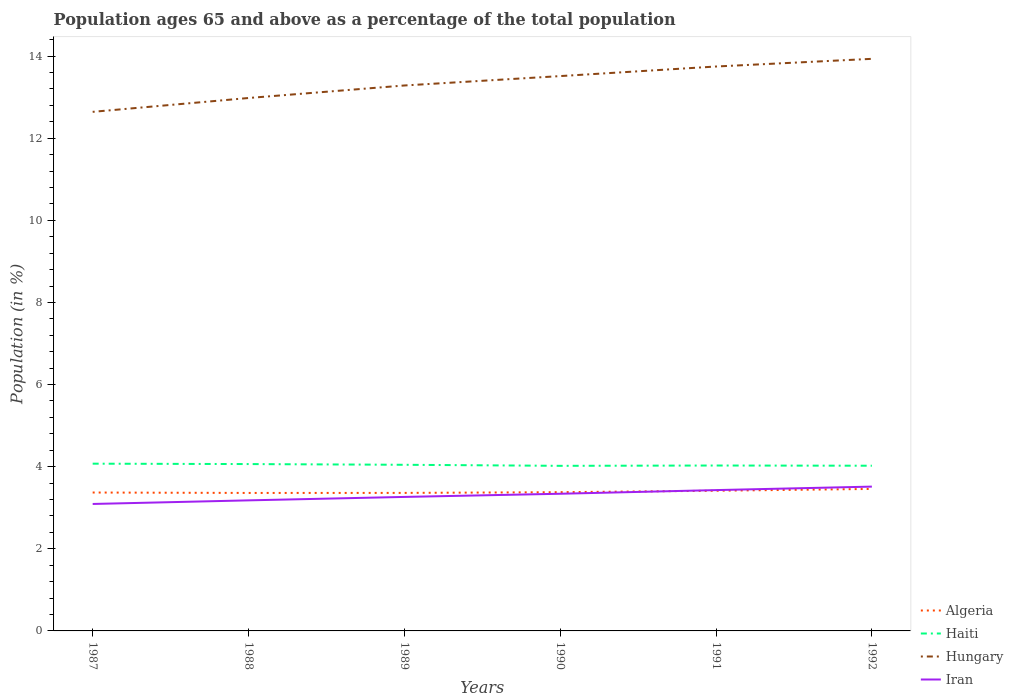How many different coloured lines are there?
Offer a terse response. 4. Across all years, what is the maximum percentage of the population ages 65 and above in Iran?
Offer a terse response. 3.09. What is the total percentage of the population ages 65 and above in Haiti in the graph?
Your response must be concise. 0. What is the difference between the highest and the second highest percentage of the population ages 65 and above in Hungary?
Ensure brevity in your answer.  1.29. What is the difference between the highest and the lowest percentage of the population ages 65 and above in Iran?
Offer a very short reply. 3. Is the percentage of the population ages 65 and above in Algeria strictly greater than the percentage of the population ages 65 and above in Hungary over the years?
Provide a succinct answer. Yes. How many lines are there?
Offer a terse response. 4. How many years are there in the graph?
Your response must be concise. 6. Are the values on the major ticks of Y-axis written in scientific E-notation?
Your response must be concise. No. Where does the legend appear in the graph?
Ensure brevity in your answer.  Bottom right. How are the legend labels stacked?
Your answer should be compact. Vertical. What is the title of the graph?
Keep it short and to the point. Population ages 65 and above as a percentage of the total population. Does "Least developed countries" appear as one of the legend labels in the graph?
Provide a short and direct response. No. What is the label or title of the X-axis?
Ensure brevity in your answer.  Years. What is the label or title of the Y-axis?
Provide a short and direct response. Population (in %). What is the Population (in %) of Algeria in 1987?
Keep it short and to the point. 3.37. What is the Population (in %) of Haiti in 1987?
Give a very brief answer. 4.07. What is the Population (in %) of Hungary in 1987?
Keep it short and to the point. 12.64. What is the Population (in %) of Iran in 1987?
Keep it short and to the point. 3.09. What is the Population (in %) in Algeria in 1988?
Offer a very short reply. 3.36. What is the Population (in %) in Haiti in 1988?
Offer a very short reply. 4.06. What is the Population (in %) of Hungary in 1988?
Keep it short and to the point. 12.98. What is the Population (in %) in Iran in 1988?
Your answer should be compact. 3.18. What is the Population (in %) in Algeria in 1989?
Provide a short and direct response. 3.36. What is the Population (in %) of Haiti in 1989?
Offer a terse response. 4.05. What is the Population (in %) of Hungary in 1989?
Offer a very short reply. 13.28. What is the Population (in %) in Iran in 1989?
Ensure brevity in your answer.  3.26. What is the Population (in %) of Algeria in 1990?
Keep it short and to the point. 3.38. What is the Population (in %) in Haiti in 1990?
Give a very brief answer. 4.02. What is the Population (in %) of Hungary in 1990?
Offer a very short reply. 13.51. What is the Population (in %) of Iran in 1990?
Your response must be concise. 3.34. What is the Population (in %) in Algeria in 1991?
Make the answer very short. 3.41. What is the Population (in %) of Haiti in 1991?
Keep it short and to the point. 4.03. What is the Population (in %) in Hungary in 1991?
Provide a short and direct response. 13.75. What is the Population (in %) in Iran in 1991?
Keep it short and to the point. 3.43. What is the Population (in %) in Algeria in 1992?
Provide a succinct answer. 3.46. What is the Population (in %) of Haiti in 1992?
Your response must be concise. 4.02. What is the Population (in %) of Hungary in 1992?
Provide a succinct answer. 13.93. What is the Population (in %) of Iran in 1992?
Your response must be concise. 3.51. Across all years, what is the maximum Population (in %) in Algeria?
Your response must be concise. 3.46. Across all years, what is the maximum Population (in %) of Haiti?
Give a very brief answer. 4.07. Across all years, what is the maximum Population (in %) in Hungary?
Keep it short and to the point. 13.93. Across all years, what is the maximum Population (in %) of Iran?
Ensure brevity in your answer.  3.51. Across all years, what is the minimum Population (in %) in Algeria?
Keep it short and to the point. 3.36. Across all years, what is the minimum Population (in %) in Haiti?
Ensure brevity in your answer.  4.02. Across all years, what is the minimum Population (in %) of Hungary?
Make the answer very short. 12.64. Across all years, what is the minimum Population (in %) in Iran?
Ensure brevity in your answer.  3.09. What is the total Population (in %) of Algeria in the graph?
Your answer should be compact. 20.34. What is the total Population (in %) in Haiti in the graph?
Offer a terse response. 24.25. What is the total Population (in %) in Hungary in the graph?
Offer a very short reply. 80.09. What is the total Population (in %) in Iran in the graph?
Ensure brevity in your answer.  19.82. What is the difference between the Population (in %) of Algeria in 1987 and that in 1988?
Keep it short and to the point. 0.01. What is the difference between the Population (in %) in Haiti in 1987 and that in 1988?
Your response must be concise. 0.01. What is the difference between the Population (in %) in Hungary in 1987 and that in 1988?
Your answer should be very brief. -0.34. What is the difference between the Population (in %) in Iran in 1987 and that in 1988?
Provide a short and direct response. -0.09. What is the difference between the Population (in %) of Algeria in 1987 and that in 1989?
Offer a very short reply. 0.01. What is the difference between the Population (in %) of Haiti in 1987 and that in 1989?
Ensure brevity in your answer.  0.03. What is the difference between the Population (in %) of Hungary in 1987 and that in 1989?
Keep it short and to the point. -0.64. What is the difference between the Population (in %) in Iran in 1987 and that in 1989?
Keep it short and to the point. -0.17. What is the difference between the Population (in %) in Algeria in 1987 and that in 1990?
Keep it short and to the point. -0.01. What is the difference between the Population (in %) in Haiti in 1987 and that in 1990?
Provide a short and direct response. 0.05. What is the difference between the Population (in %) of Hungary in 1987 and that in 1990?
Your response must be concise. -0.87. What is the difference between the Population (in %) in Iran in 1987 and that in 1990?
Give a very brief answer. -0.25. What is the difference between the Population (in %) in Algeria in 1987 and that in 1991?
Offer a very short reply. -0.04. What is the difference between the Population (in %) in Haiti in 1987 and that in 1991?
Give a very brief answer. 0.04. What is the difference between the Population (in %) of Hungary in 1987 and that in 1991?
Your answer should be very brief. -1.1. What is the difference between the Population (in %) in Iran in 1987 and that in 1991?
Your answer should be compact. -0.34. What is the difference between the Population (in %) in Algeria in 1987 and that in 1992?
Provide a short and direct response. -0.09. What is the difference between the Population (in %) of Haiti in 1987 and that in 1992?
Your answer should be compact. 0.05. What is the difference between the Population (in %) of Hungary in 1987 and that in 1992?
Keep it short and to the point. -1.29. What is the difference between the Population (in %) in Iran in 1987 and that in 1992?
Provide a short and direct response. -0.42. What is the difference between the Population (in %) of Algeria in 1988 and that in 1989?
Give a very brief answer. -0. What is the difference between the Population (in %) in Haiti in 1988 and that in 1989?
Offer a very short reply. 0.02. What is the difference between the Population (in %) in Hungary in 1988 and that in 1989?
Give a very brief answer. -0.3. What is the difference between the Population (in %) of Iran in 1988 and that in 1989?
Give a very brief answer. -0.08. What is the difference between the Population (in %) in Algeria in 1988 and that in 1990?
Give a very brief answer. -0.02. What is the difference between the Population (in %) in Haiti in 1988 and that in 1990?
Offer a terse response. 0.04. What is the difference between the Population (in %) in Hungary in 1988 and that in 1990?
Give a very brief answer. -0.53. What is the difference between the Population (in %) in Iran in 1988 and that in 1990?
Provide a short and direct response. -0.16. What is the difference between the Population (in %) of Algeria in 1988 and that in 1991?
Your answer should be very brief. -0.05. What is the difference between the Population (in %) in Haiti in 1988 and that in 1991?
Provide a succinct answer. 0.04. What is the difference between the Population (in %) of Hungary in 1988 and that in 1991?
Your answer should be very brief. -0.77. What is the difference between the Population (in %) of Iran in 1988 and that in 1991?
Provide a short and direct response. -0.25. What is the difference between the Population (in %) of Algeria in 1988 and that in 1992?
Ensure brevity in your answer.  -0.1. What is the difference between the Population (in %) of Haiti in 1988 and that in 1992?
Ensure brevity in your answer.  0.04. What is the difference between the Population (in %) in Hungary in 1988 and that in 1992?
Your response must be concise. -0.95. What is the difference between the Population (in %) of Iran in 1988 and that in 1992?
Provide a short and direct response. -0.34. What is the difference between the Population (in %) of Algeria in 1989 and that in 1990?
Keep it short and to the point. -0.02. What is the difference between the Population (in %) of Haiti in 1989 and that in 1990?
Your answer should be very brief. 0.03. What is the difference between the Population (in %) of Hungary in 1989 and that in 1990?
Provide a short and direct response. -0.23. What is the difference between the Population (in %) of Iran in 1989 and that in 1990?
Offer a very short reply. -0.08. What is the difference between the Population (in %) of Algeria in 1989 and that in 1991?
Your answer should be compact. -0.05. What is the difference between the Population (in %) in Haiti in 1989 and that in 1991?
Your answer should be very brief. 0.02. What is the difference between the Population (in %) of Hungary in 1989 and that in 1991?
Your response must be concise. -0.46. What is the difference between the Population (in %) of Iran in 1989 and that in 1991?
Keep it short and to the point. -0.17. What is the difference between the Population (in %) in Algeria in 1989 and that in 1992?
Your answer should be very brief. -0.1. What is the difference between the Population (in %) of Haiti in 1989 and that in 1992?
Your answer should be compact. 0.02. What is the difference between the Population (in %) of Hungary in 1989 and that in 1992?
Your response must be concise. -0.65. What is the difference between the Population (in %) in Iran in 1989 and that in 1992?
Keep it short and to the point. -0.25. What is the difference between the Population (in %) of Algeria in 1990 and that in 1991?
Your response must be concise. -0.04. What is the difference between the Population (in %) in Haiti in 1990 and that in 1991?
Ensure brevity in your answer.  -0.01. What is the difference between the Population (in %) of Hungary in 1990 and that in 1991?
Give a very brief answer. -0.23. What is the difference between the Population (in %) in Iran in 1990 and that in 1991?
Your answer should be very brief. -0.09. What is the difference between the Population (in %) of Algeria in 1990 and that in 1992?
Your answer should be compact. -0.08. What is the difference between the Population (in %) of Haiti in 1990 and that in 1992?
Your response must be concise. -0. What is the difference between the Population (in %) of Hungary in 1990 and that in 1992?
Your response must be concise. -0.42. What is the difference between the Population (in %) of Iran in 1990 and that in 1992?
Make the answer very short. -0.17. What is the difference between the Population (in %) of Algeria in 1991 and that in 1992?
Your response must be concise. -0.04. What is the difference between the Population (in %) in Haiti in 1991 and that in 1992?
Your response must be concise. 0. What is the difference between the Population (in %) of Hungary in 1991 and that in 1992?
Ensure brevity in your answer.  -0.19. What is the difference between the Population (in %) of Iran in 1991 and that in 1992?
Provide a short and direct response. -0.09. What is the difference between the Population (in %) of Algeria in 1987 and the Population (in %) of Haiti in 1988?
Your answer should be compact. -0.69. What is the difference between the Population (in %) in Algeria in 1987 and the Population (in %) in Hungary in 1988?
Keep it short and to the point. -9.61. What is the difference between the Population (in %) of Algeria in 1987 and the Population (in %) of Iran in 1988?
Give a very brief answer. 0.19. What is the difference between the Population (in %) in Haiti in 1987 and the Population (in %) in Hungary in 1988?
Give a very brief answer. -8.91. What is the difference between the Population (in %) in Haiti in 1987 and the Population (in %) in Iran in 1988?
Offer a very short reply. 0.89. What is the difference between the Population (in %) in Hungary in 1987 and the Population (in %) in Iran in 1988?
Provide a succinct answer. 9.46. What is the difference between the Population (in %) in Algeria in 1987 and the Population (in %) in Haiti in 1989?
Your answer should be compact. -0.68. What is the difference between the Population (in %) of Algeria in 1987 and the Population (in %) of Hungary in 1989?
Offer a very short reply. -9.91. What is the difference between the Population (in %) in Algeria in 1987 and the Population (in %) in Iran in 1989?
Make the answer very short. 0.11. What is the difference between the Population (in %) of Haiti in 1987 and the Population (in %) of Hungary in 1989?
Ensure brevity in your answer.  -9.21. What is the difference between the Population (in %) in Haiti in 1987 and the Population (in %) in Iran in 1989?
Ensure brevity in your answer.  0.81. What is the difference between the Population (in %) in Hungary in 1987 and the Population (in %) in Iran in 1989?
Keep it short and to the point. 9.38. What is the difference between the Population (in %) in Algeria in 1987 and the Population (in %) in Haiti in 1990?
Your answer should be very brief. -0.65. What is the difference between the Population (in %) in Algeria in 1987 and the Population (in %) in Hungary in 1990?
Keep it short and to the point. -10.14. What is the difference between the Population (in %) in Algeria in 1987 and the Population (in %) in Iran in 1990?
Offer a terse response. 0.03. What is the difference between the Population (in %) in Haiti in 1987 and the Population (in %) in Hungary in 1990?
Offer a very short reply. -9.44. What is the difference between the Population (in %) of Haiti in 1987 and the Population (in %) of Iran in 1990?
Make the answer very short. 0.73. What is the difference between the Population (in %) of Hungary in 1987 and the Population (in %) of Iran in 1990?
Offer a terse response. 9.3. What is the difference between the Population (in %) of Algeria in 1987 and the Population (in %) of Haiti in 1991?
Provide a short and direct response. -0.66. What is the difference between the Population (in %) in Algeria in 1987 and the Population (in %) in Hungary in 1991?
Offer a very short reply. -10.37. What is the difference between the Population (in %) in Algeria in 1987 and the Population (in %) in Iran in 1991?
Ensure brevity in your answer.  -0.06. What is the difference between the Population (in %) in Haiti in 1987 and the Population (in %) in Hungary in 1991?
Provide a short and direct response. -9.67. What is the difference between the Population (in %) in Haiti in 1987 and the Population (in %) in Iran in 1991?
Offer a terse response. 0.64. What is the difference between the Population (in %) in Hungary in 1987 and the Population (in %) in Iran in 1991?
Your answer should be very brief. 9.21. What is the difference between the Population (in %) of Algeria in 1987 and the Population (in %) of Haiti in 1992?
Give a very brief answer. -0.65. What is the difference between the Population (in %) in Algeria in 1987 and the Population (in %) in Hungary in 1992?
Your response must be concise. -10.56. What is the difference between the Population (in %) of Algeria in 1987 and the Population (in %) of Iran in 1992?
Keep it short and to the point. -0.14. What is the difference between the Population (in %) in Haiti in 1987 and the Population (in %) in Hungary in 1992?
Your answer should be compact. -9.86. What is the difference between the Population (in %) of Haiti in 1987 and the Population (in %) of Iran in 1992?
Ensure brevity in your answer.  0.56. What is the difference between the Population (in %) in Hungary in 1987 and the Population (in %) in Iran in 1992?
Your response must be concise. 9.13. What is the difference between the Population (in %) in Algeria in 1988 and the Population (in %) in Haiti in 1989?
Offer a terse response. -0.69. What is the difference between the Population (in %) of Algeria in 1988 and the Population (in %) of Hungary in 1989?
Offer a terse response. -9.92. What is the difference between the Population (in %) of Algeria in 1988 and the Population (in %) of Iran in 1989?
Offer a terse response. 0.1. What is the difference between the Population (in %) of Haiti in 1988 and the Population (in %) of Hungary in 1989?
Offer a very short reply. -9.22. What is the difference between the Population (in %) of Haiti in 1988 and the Population (in %) of Iran in 1989?
Keep it short and to the point. 0.8. What is the difference between the Population (in %) of Hungary in 1988 and the Population (in %) of Iran in 1989?
Ensure brevity in your answer.  9.71. What is the difference between the Population (in %) of Algeria in 1988 and the Population (in %) of Haiti in 1990?
Your response must be concise. -0.66. What is the difference between the Population (in %) of Algeria in 1988 and the Population (in %) of Hungary in 1990?
Offer a terse response. -10.15. What is the difference between the Population (in %) in Algeria in 1988 and the Population (in %) in Iran in 1990?
Give a very brief answer. 0.02. What is the difference between the Population (in %) of Haiti in 1988 and the Population (in %) of Hungary in 1990?
Your answer should be compact. -9.45. What is the difference between the Population (in %) of Haiti in 1988 and the Population (in %) of Iran in 1990?
Offer a terse response. 0.72. What is the difference between the Population (in %) of Hungary in 1988 and the Population (in %) of Iran in 1990?
Your response must be concise. 9.64. What is the difference between the Population (in %) in Algeria in 1988 and the Population (in %) in Haiti in 1991?
Make the answer very short. -0.67. What is the difference between the Population (in %) of Algeria in 1988 and the Population (in %) of Hungary in 1991?
Keep it short and to the point. -10.39. What is the difference between the Population (in %) in Algeria in 1988 and the Population (in %) in Iran in 1991?
Offer a terse response. -0.07. What is the difference between the Population (in %) of Haiti in 1988 and the Population (in %) of Hungary in 1991?
Offer a very short reply. -9.68. What is the difference between the Population (in %) in Haiti in 1988 and the Population (in %) in Iran in 1991?
Provide a short and direct response. 0.63. What is the difference between the Population (in %) in Hungary in 1988 and the Population (in %) in Iran in 1991?
Provide a short and direct response. 9.55. What is the difference between the Population (in %) in Algeria in 1988 and the Population (in %) in Haiti in 1992?
Provide a succinct answer. -0.66. What is the difference between the Population (in %) of Algeria in 1988 and the Population (in %) of Hungary in 1992?
Make the answer very short. -10.57. What is the difference between the Population (in %) of Algeria in 1988 and the Population (in %) of Iran in 1992?
Ensure brevity in your answer.  -0.15. What is the difference between the Population (in %) in Haiti in 1988 and the Population (in %) in Hungary in 1992?
Your answer should be very brief. -9.87. What is the difference between the Population (in %) of Haiti in 1988 and the Population (in %) of Iran in 1992?
Make the answer very short. 0.55. What is the difference between the Population (in %) in Hungary in 1988 and the Population (in %) in Iran in 1992?
Give a very brief answer. 9.46. What is the difference between the Population (in %) of Algeria in 1989 and the Population (in %) of Haiti in 1990?
Offer a terse response. -0.66. What is the difference between the Population (in %) in Algeria in 1989 and the Population (in %) in Hungary in 1990?
Make the answer very short. -10.15. What is the difference between the Population (in %) in Algeria in 1989 and the Population (in %) in Iran in 1990?
Ensure brevity in your answer.  0.02. What is the difference between the Population (in %) in Haiti in 1989 and the Population (in %) in Hungary in 1990?
Offer a terse response. -9.47. What is the difference between the Population (in %) in Haiti in 1989 and the Population (in %) in Iran in 1990?
Your answer should be compact. 0.71. What is the difference between the Population (in %) of Hungary in 1989 and the Population (in %) of Iran in 1990?
Ensure brevity in your answer.  9.94. What is the difference between the Population (in %) in Algeria in 1989 and the Population (in %) in Haiti in 1991?
Your answer should be compact. -0.67. What is the difference between the Population (in %) of Algeria in 1989 and the Population (in %) of Hungary in 1991?
Offer a very short reply. -10.38. What is the difference between the Population (in %) in Algeria in 1989 and the Population (in %) in Iran in 1991?
Your response must be concise. -0.07. What is the difference between the Population (in %) of Haiti in 1989 and the Population (in %) of Hungary in 1991?
Your answer should be compact. -9.7. What is the difference between the Population (in %) in Haiti in 1989 and the Population (in %) in Iran in 1991?
Keep it short and to the point. 0.62. What is the difference between the Population (in %) of Hungary in 1989 and the Population (in %) of Iran in 1991?
Your answer should be compact. 9.85. What is the difference between the Population (in %) in Algeria in 1989 and the Population (in %) in Haiti in 1992?
Provide a succinct answer. -0.66. What is the difference between the Population (in %) of Algeria in 1989 and the Population (in %) of Hungary in 1992?
Offer a very short reply. -10.57. What is the difference between the Population (in %) in Algeria in 1989 and the Population (in %) in Iran in 1992?
Make the answer very short. -0.15. What is the difference between the Population (in %) of Haiti in 1989 and the Population (in %) of Hungary in 1992?
Give a very brief answer. -9.89. What is the difference between the Population (in %) of Haiti in 1989 and the Population (in %) of Iran in 1992?
Your answer should be very brief. 0.53. What is the difference between the Population (in %) of Hungary in 1989 and the Population (in %) of Iran in 1992?
Make the answer very short. 9.77. What is the difference between the Population (in %) of Algeria in 1990 and the Population (in %) of Haiti in 1991?
Offer a very short reply. -0.65. What is the difference between the Population (in %) of Algeria in 1990 and the Population (in %) of Hungary in 1991?
Give a very brief answer. -10.37. What is the difference between the Population (in %) of Algeria in 1990 and the Population (in %) of Iran in 1991?
Ensure brevity in your answer.  -0.05. What is the difference between the Population (in %) of Haiti in 1990 and the Population (in %) of Hungary in 1991?
Your response must be concise. -9.72. What is the difference between the Population (in %) of Haiti in 1990 and the Population (in %) of Iran in 1991?
Your answer should be very brief. 0.59. What is the difference between the Population (in %) of Hungary in 1990 and the Population (in %) of Iran in 1991?
Offer a terse response. 10.08. What is the difference between the Population (in %) in Algeria in 1990 and the Population (in %) in Haiti in 1992?
Your answer should be very brief. -0.64. What is the difference between the Population (in %) in Algeria in 1990 and the Population (in %) in Hungary in 1992?
Give a very brief answer. -10.55. What is the difference between the Population (in %) of Algeria in 1990 and the Population (in %) of Iran in 1992?
Ensure brevity in your answer.  -0.14. What is the difference between the Population (in %) in Haiti in 1990 and the Population (in %) in Hungary in 1992?
Keep it short and to the point. -9.91. What is the difference between the Population (in %) of Haiti in 1990 and the Population (in %) of Iran in 1992?
Your answer should be compact. 0.51. What is the difference between the Population (in %) in Hungary in 1990 and the Population (in %) in Iran in 1992?
Keep it short and to the point. 10. What is the difference between the Population (in %) of Algeria in 1991 and the Population (in %) of Haiti in 1992?
Provide a short and direct response. -0.61. What is the difference between the Population (in %) in Algeria in 1991 and the Population (in %) in Hungary in 1992?
Offer a terse response. -10.52. What is the difference between the Population (in %) of Algeria in 1991 and the Population (in %) of Iran in 1992?
Offer a very short reply. -0.1. What is the difference between the Population (in %) of Haiti in 1991 and the Population (in %) of Hungary in 1992?
Your answer should be compact. -9.9. What is the difference between the Population (in %) of Haiti in 1991 and the Population (in %) of Iran in 1992?
Your answer should be very brief. 0.51. What is the difference between the Population (in %) of Hungary in 1991 and the Population (in %) of Iran in 1992?
Your response must be concise. 10.23. What is the average Population (in %) of Algeria per year?
Your answer should be compact. 3.39. What is the average Population (in %) of Haiti per year?
Provide a short and direct response. 4.04. What is the average Population (in %) of Hungary per year?
Give a very brief answer. 13.35. What is the average Population (in %) in Iran per year?
Offer a very short reply. 3.3. In the year 1987, what is the difference between the Population (in %) in Algeria and Population (in %) in Haiti?
Make the answer very short. -0.7. In the year 1987, what is the difference between the Population (in %) in Algeria and Population (in %) in Hungary?
Give a very brief answer. -9.27. In the year 1987, what is the difference between the Population (in %) in Algeria and Population (in %) in Iran?
Make the answer very short. 0.28. In the year 1987, what is the difference between the Population (in %) of Haiti and Population (in %) of Hungary?
Keep it short and to the point. -8.57. In the year 1987, what is the difference between the Population (in %) in Haiti and Population (in %) in Iran?
Offer a very short reply. 0.98. In the year 1987, what is the difference between the Population (in %) of Hungary and Population (in %) of Iran?
Keep it short and to the point. 9.55. In the year 1988, what is the difference between the Population (in %) in Algeria and Population (in %) in Haiti?
Offer a terse response. -0.7. In the year 1988, what is the difference between the Population (in %) in Algeria and Population (in %) in Hungary?
Your response must be concise. -9.62. In the year 1988, what is the difference between the Population (in %) in Algeria and Population (in %) in Iran?
Provide a short and direct response. 0.18. In the year 1988, what is the difference between the Population (in %) in Haiti and Population (in %) in Hungary?
Provide a short and direct response. -8.91. In the year 1988, what is the difference between the Population (in %) in Haiti and Population (in %) in Iran?
Your response must be concise. 0.88. In the year 1988, what is the difference between the Population (in %) of Hungary and Population (in %) of Iran?
Ensure brevity in your answer.  9.8. In the year 1989, what is the difference between the Population (in %) of Algeria and Population (in %) of Haiti?
Your response must be concise. -0.68. In the year 1989, what is the difference between the Population (in %) of Algeria and Population (in %) of Hungary?
Your response must be concise. -9.92. In the year 1989, what is the difference between the Population (in %) in Algeria and Population (in %) in Iran?
Give a very brief answer. 0.1. In the year 1989, what is the difference between the Population (in %) of Haiti and Population (in %) of Hungary?
Keep it short and to the point. -9.24. In the year 1989, what is the difference between the Population (in %) in Haiti and Population (in %) in Iran?
Your response must be concise. 0.78. In the year 1989, what is the difference between the Population (in %) of Hungary and Population (in %) of Iran?
Offer a very short reply. 10.02. In the year 1990, what is the difference between the Population (in %) in Algeria and Population (in %) in Haiti?
Your answer should be very brief. -0.64. In the year 1990, what is the difference between the Population (in %) of Algeria and Population (in %) of Hungary?
Provide a short and direct response. -10.13. In the year 1990, what is the difference between the Population (in %) of Algeria and Population (in %) of Iran?
Give a very brief answer. 0.04. In the year 1990, what is the difference between the Population (in %) of Haiti and Population (in %) of Hungary?
Offer a very short reply. -9.49. In the year 1990, what is the difference between the Population (in %) of Haiti and Population (in %) of Iran?
Give a very brief answer. 0.68. In the year 1990, what is the difference between the Population (in %) in Hungary and Population (in %) in Iran?
Provide a short and direct response. 10.17. In the year 1991, what is the difference between the Population (in %) of Algeria and Population (in %) of Haiti?
Ensure brevity in your answer.  -0.61. In the year 1991, what is the difference between the Population (in %) of Algeria and Population (in %) of Hungary?
Your answer should be very brief. -10.33. In the year 1991, what is the difference between the Population (in %) in Algeria and Population (in %) in Iran?
Offer a very short reply. -0.02. In the year 1991, what is the difference between the Population (in %) in Haiti and Population (in %) in Hungary?
Keep it short and to the point. -9.72. In the year 1991, what is the difference between the Population (in %) in Haiti and Population (in %) in Iran?
Make the answer very short. 0.6. In the year 1991, what is the difference between the Population (in %) in Hungary and Population (in %) in Iran?
Give a very brief answer. 10.32. In the year 1992, what is the difference between the Population (in %) in Algeria and Population (in %) in Haiti?
Keep it short and to the point. -0.57. In the year 1992, what is the difference between the Population (in %) in Algeria and Population (in %) in Hungary?
Keep it short and to the point. -10.47. In the year 1992, what is the difference between the Population (in %) of Algeria and Population (in %) of Iran?
Provide a short and direct response. -0.06. In the year 1992, what is the difference between the Population (in %) of Haiti and Population (in %) of Hungary?
Provide a succinct answer. -9.91. In the year 1992, what is the difference between the Population (in %) in Haiti and Population (in %) in Iran?
Keep it short and to the point. 0.51. In the year 1992, what is the difference between the Population (in %) of Hungary and Population (in %) of Iran?
Ensure brevity in your answer.  10.42. What is the ratio of the Population (in %) in Algeria in 1987 to that in 1988?
Keep it short and to the point. 1. What is the ratio of the Population (in %) of Iran in 1987 to that in 1988?
Give a very brief answer. 0.97. What is the ratio of the Population (in %) in Algeria in 1987 to that in 1989?
Give a very brief answer. 1. What is the ratio of the Population (in %) in Haiti in 1987 to that in 1989?
Keep it short and to the point. 1.01. What is the ratio of the Population (in %) in Hungary in 1987 to that in 1989?
Provide a succinct answer. 0.95. What is the ratio of the Population (in %) of Iran in 1987 to that in 1989?
Provide a short and direct response. 0.95. What is the ratio of the Population (in %) in Algeria in 1987 to that in 1990?
Offer a very short reply. 1. What is the ratio of the Population (in %) in Haiti in 1987 to that in 1990?
Make the answer very short. 1.01. What is the ratio of the Population (in %) in Hungary in 1987 to that in 1990?
Ensure brevity in your answer.  0.94. What is the ratio of the Population (in %) in Iran in 1987 to that in 1990?
Give a very brief answer. 0.93. What is the ratio of the Population (in %) of Algeria in 1987 to that in 1991?
Offer a terse response. 0.99. What is the ratio of the Population (in %) of Haiti in 1987 to that in 1991?
Provide a succinct answer. 1.01. What is the ratio of the Population (in %) of Hungary in 1987 to that in 1991?
Ensure brevity in your answer.  0.92. What is the ratio of the Population (in %) of Iran in 1987 to that in 1991?
Your answer should be compact. 0.9. What is the ratio of the Population (in %) in Algeria in 1987 to that in 1992?
Your answer should be compact. 0.97. What is the ratio of the Population (in %) of Haiti in 1987 to that in 1992?
Make the answer very short. 1.01. What is the ratio of the Population (in %) of Hungary in 1987 to that in 1992?
Offer a terse response. 0.91. What is the ratio of the Population (in %) in Iran in 1987 to that in 1992?
Provide a succinct answer. 0.88. What is the ratio of the Population (in %) of Algeria in 1988 to that in 1989?
Your response must be concise. 1. What is the ratio of the Population (in %) in Haiti in 1988 to that in 1989?
Give a very brief answer. 1. What is the ratio of the Population (in %) of Iran in 1988 to that in 1989?
Your answer should be very brief. 0.97. What is the ratio of the Population (in %) of Algeria in 1988 to that in 1990?
Make the answer very short. 0.99. What is the ratio of the Population (in %) of Haiti in 1988 to that in 1990?
Your response must be concise. 1.01. What is the ratio of the Population (in %) in Hungary in 1988 to that in 1990?
Offer a very short reply. 0.96. What is the ratio of the Population (in %) in Iran in 1988 to that in 1990?
Provide a short and direct response. 0.95. What is the ratio of the Population (in %) in Algeria in 1988 to that in 1991?
Provide a succinct answer. 0.98. What is the ratio of the Population (in %) of Haiti in 1988 to that in 1991?
Offer a terse response. 1.01. What is the ratio of the Population (in %) of Hungary in 1988 to that in 1991?
Provide a succinct answer. 0.94. What is the ratio of the Population (in %) of Iran in 1988 to that in 1991?
Keep it short and to the point. 0.93. What is the ratio of the Population (in %) of Algeria in 1988 to that in 1992?
Keep it short and to the point. 0.97. What is the ratio of the Population (in %) in Haiti in 1988 to that in 1992?
Keep it short and to the point. 1.01. What is the ratio of the Population (in %) of Hungary in 1988 to that in 1992?
Your answer should be very brief. 0.93. What is the ratio of the Population (in %) of Iran in 1988 to that in 1992?
Your answer should be compact. 0.9. What is the ratio of the Population (in %) in Haiti in 1989 to that in 1990?
Make the answer very short. 1.01. What is the ratio of the Population (in %) in Hungary in 1989 to that in 1990?
Your answer should be compact. 0.98. What is the ratio of the Population (in %) in Iran in 1989 to that in 1990?
Your answer should be very brief. 0.98. What is the ratio of the Population (in %) of Algeria in 1989 to that in 1991?
Your response must be concise. 0.98. What is the ratio of the Population (in %) of Hungary in 1989 to that in 1991?
Make the answer very short. 0.97. What is the ratio of the Population (in %) in Iran in 1989 to that in 1991?
Keep it short and to the point. 0.95. What is the ratio of the Population (in %) of Algeria in 1989 to that in 1992?
Your answer should be very brief. 0.97. What is the ratio of the Population (in %) of Hungary in 1989 to that in 1992?
Your response must be concise. 0.95. What is the ratio of the Population (in %) of Iran in 1989 to that in 1992?
Your answer should be very brief. 0.93. What is the ratio of the Population (in %) in Algeria in 1990 to that in 1991?
Ensure brevity in your answer.  0.99. What is the ratio of the Population (in %) in Iran in 1990 to that in 1991?
Keep it short and to the point. 0.97. What is the ratio of the Population (in %) of Algeria in 1990 to that in 1992?
Give a very brief answer. 0.98. What is the ratio of the Population (in %) of Haiti in 1990 to that in 1992?
Provide a succinct answer. 1. What is the ratio of the Population (in %) in Hungary in 1990 to that in 1992?
Offer a very short reply. 0.97. What is the ratio of the Population (in %) in Iran in 1990 to that in 1992?
Offer a terse response. 0.95. What is the ratio of the Population (in %) of Algeria in 1991 to that in 1992?
Offer a terse response. 0.99. What is the ratio of the Population (in %) in Haiti in 1991 to that in 1992?
Offer a terse response. 1. What is the ratio of the Population (in %) in Hungary in 1991 to that in 1992?
Make the answer very short. 0.99. What is the ratio of the Population (in %) of Iran in 1991 to that in 1992?
Your answer should be compact. 0.98. What is the difference between the highest and the second highest Population (in %) of Algeria?
Ensure brevity in your answer.  0.04. What is the difference between the highest and the second highest Population (in %) of Haiti?
Keep it short and to the point. 0.01. What is the difference between the highest and the second highest Population (in %) in Hungary?
Offer a very short reply. 0.19. What is the difference between the highest and the second highest Population (in %) of Iran?
Offer a very short reply. 0.09. What is the difference between the highest and the lowest Population (in %) in Algeria?
Your answer should be compact. 0.1. What is the difference between the highest and the lowest Population (in %) in Haiti?
Ensure brevity in your answer.  0.05. What is the difference between the highest and the lowest Population (in %) of Hungary?
Your response must be concise. 1.29. What is the difference between the highest and the lowest Population (in %) in Iran?
Your response must be concise. 0.42. 